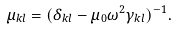Convert formula to latex. <formula><loc_0><loc_0><loc_500><loc_500>\mu _ { k l } = ( \delta _ { k l } - \mu _ { 0 } \omega ^ { 2 } \gamma _ { k l } ) ^ { - 1 } .</formula> 